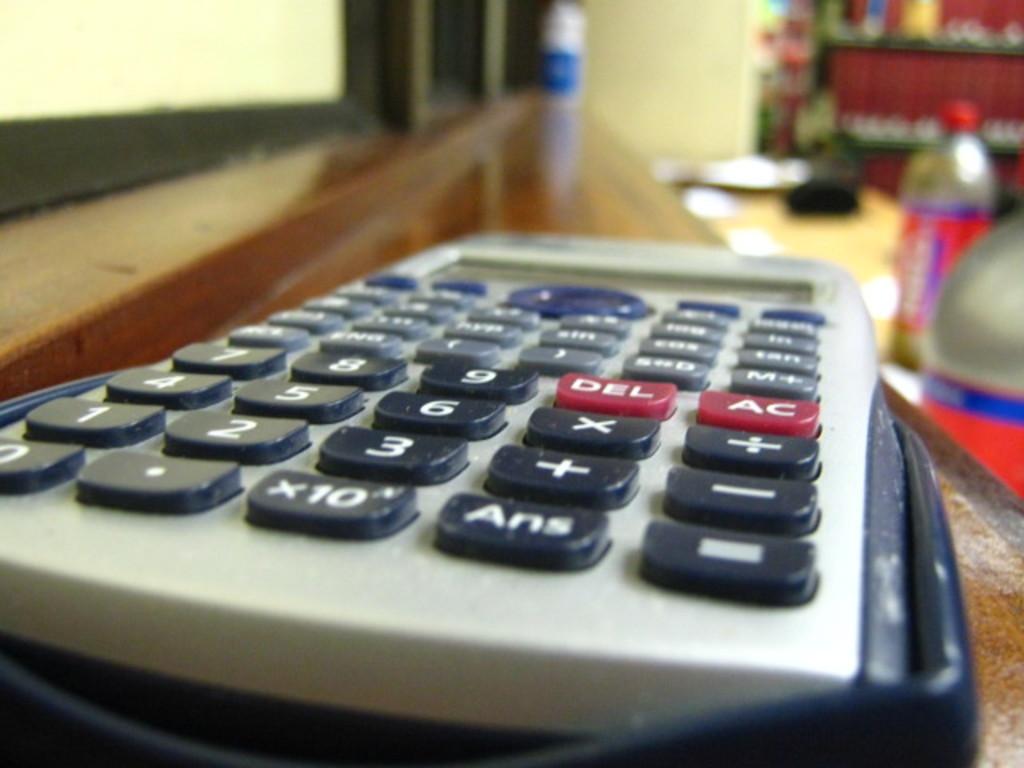What do the red buttons do?
Your response must be concise. Del ac. 